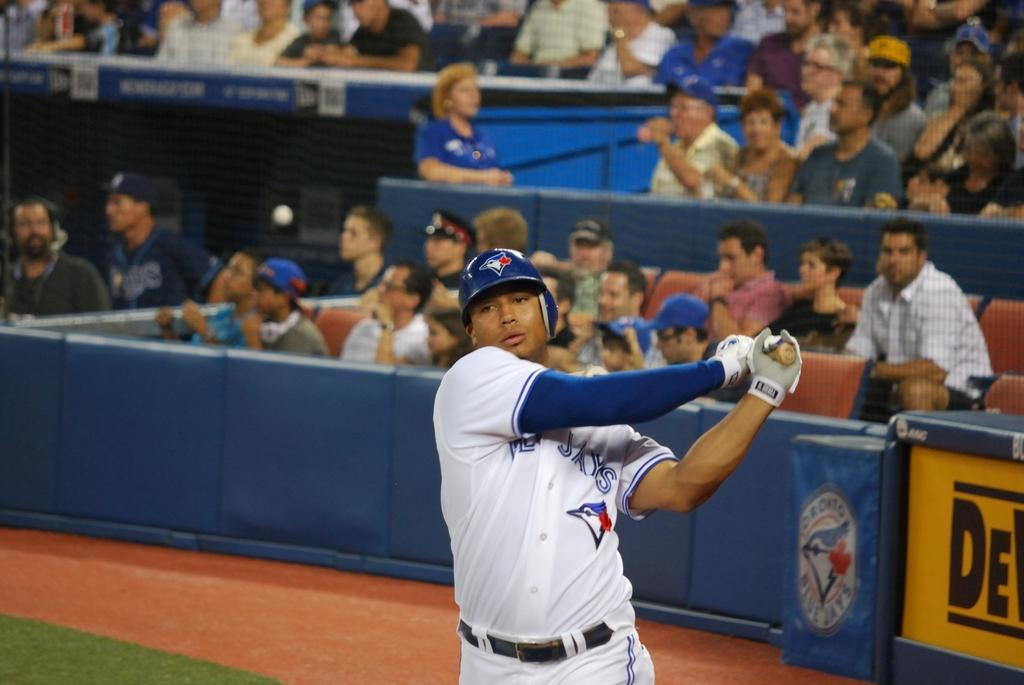<image>
Give a short and clear explanation of the subsequent image. A player for the Jays swings his bat while wearing a blue helmet. 